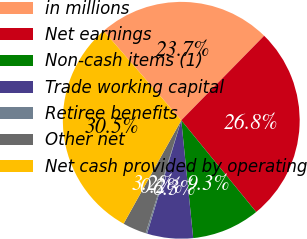Convert chart. <chart><loc_0><loc_0><loc_500><loc_500><pie_chart><fcel>in millions<fcel>Net earnings<fcel>Non-cash items (1)<fcel>Trade working capital<fcel>Retiree benefits<fcel>Other net<fcel>Net cash provided by operating<nl><fcel>23.72%<fcel>26.75%<fcel>9.3%<fcel>6.27%<fcel>0.2%<fcel>3.23%<fcel>30.53%<nl></chart> 